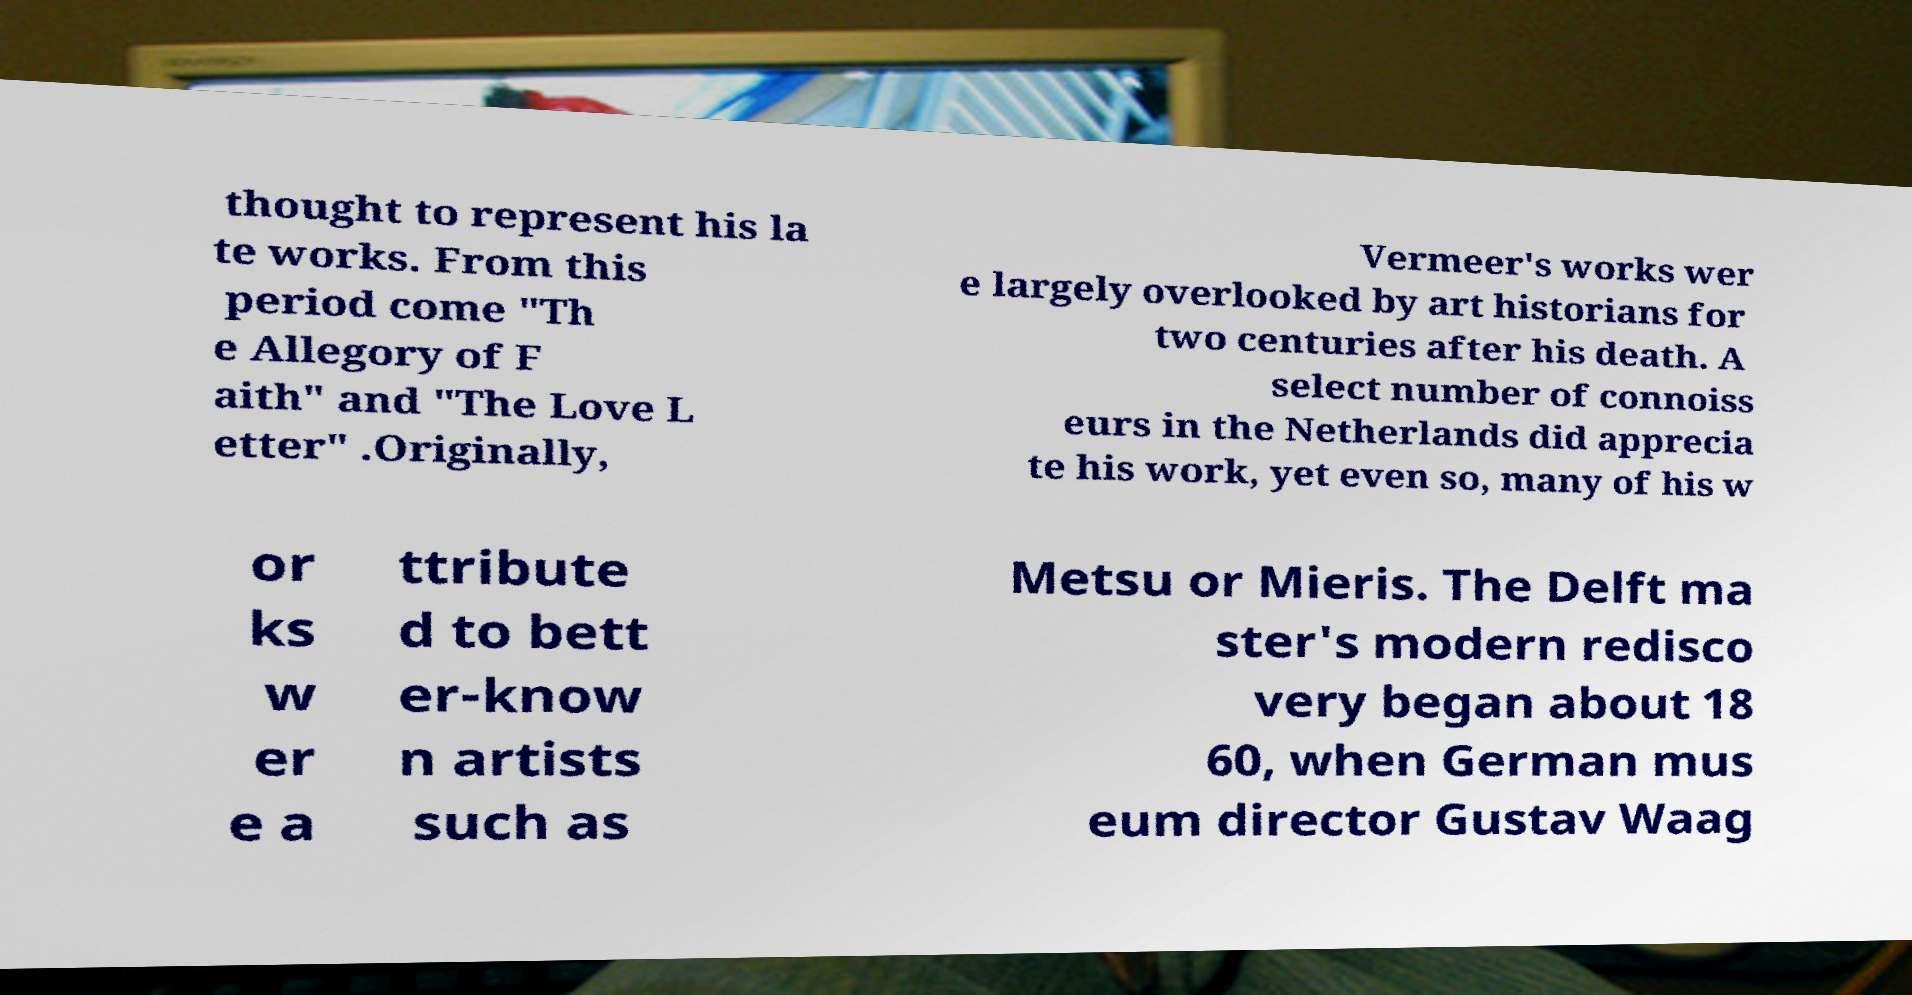Please identify and transcribe the text found in this image. thought to represent his la te works. From this period come "Th e Allegory of F aith" and "The Love L etter" .Originally, Vermeer's works wer e largely overlooked by art historians for two centuries after his death. A select number of connoiss eurs in the Netherlands did apprecia te his work, yet even so, many of his w or ks w er e a ttribute d to bett er-know n artists such as Metsu or Mieris. The Delft ma ster's modern redisco very began about 18 60, when German mus eum director Gustav Waag 